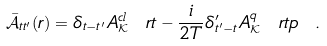<formula> <loc_0><loc_0><loc_500><loc_500>\bar { \mathcal { A } } _ { t t ^ { \prime } } ( r ) = \delta _ { t - t ^ { \prime } } A ^ { c l } _ { \mathcal { K } } \ r t - \frac { i } { 2 T } \delta ^ { \prime } _ { t ^ { \prime } - t } A ^ { q } _ { \mathcal { K } } \ r t p \ .</formula> 